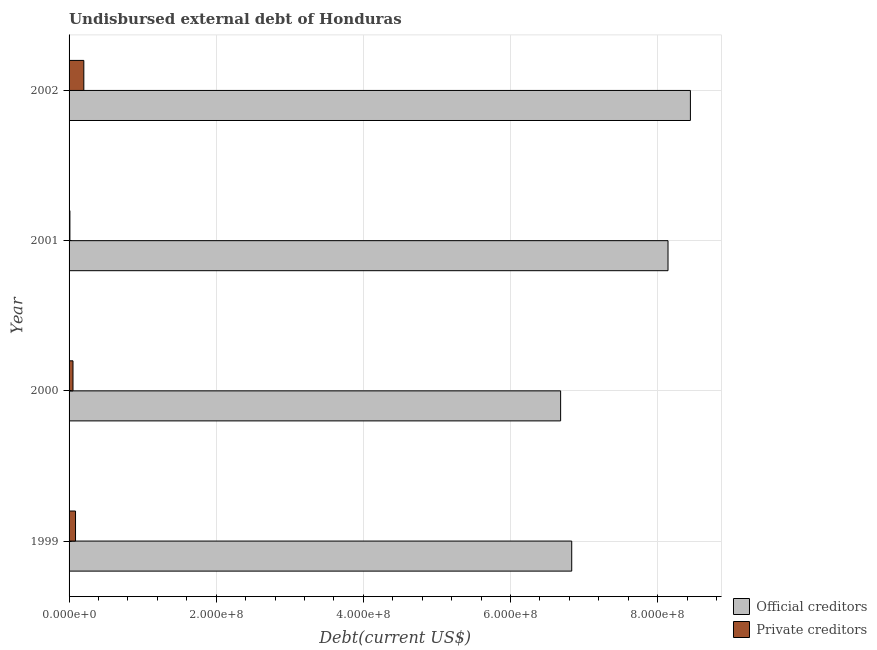How many different coloured bars are there?
Give a very brief answer. 2. Are the number of bars per tick equal to the number of legend labels?
Give a very brief answer. Yes. In how many cases, is the number of bars for a given year not equal to the number of legend labels?
Offer a terse response. 0. What is the undisbursed external debt of official creditors in 1999?
Make the answer very short. 6.83e+08. Across all years, what is the maximum undisbursed external debt of official creditors?
Give a very brief answer. 8.45e+08. Across all years, what is the minimum undisbursed external debt of official creditors?
Keep it short and to the point. 6.68e+08. In which year was the undisbursed external debt of private creditors minimum?
Ensure brevity in your answer.  2001. What is the total undisbursed external debt of private creditors in the graph?
Offer a very short reply. 3.53e+07. What is the difference between the undisbursed external debt of official creditors in 2000 and that in 2001?
Your response must be concise. -1.46e+08. What is the difference between the undisbursed external debt of official creditors in 2002 and the undisbursed external debt of private creditors in 1999?
Make the answer very short. 8.36e+08. What is the average undisbursed external debt of private creditors per year?
Keep it short and to the point. 8.83e+06. In the year 2001, what is the difference between the undisbursed external debt of private creditors and undisbursed external debt of official creditors?
Keep it short and to the point. -8.13e+08. In how many years, is the undisbursed external debt of private creditors greater than 240000000 US$?
Make the answer very short. 0. What is the ratio of the undisbursed external debt of private creditors in 2000 to that in 2002?
Give a very brief answer. 0.27. What is the difference between the highest and the second highest undisbursed external debt of official creditors?
Make the answer very short. 3.04e+07. What is the difference between the highest and the lowest undisbursed external debt of official creditors?
Keep it short and to the point. 1.76e+08. What does the 2nd bar from the top in 1999 represents?
Give a very brief answer. Official creditors. What does the 2nd bar from the bottom in 2000 represents?
Offer a very short reply. Private creditors. Are all the bars in the graph horizontal?
Provide a succinct answer. Yes. What is the difference between two consecutive major ticks on the X-axis?
Make the answer very short. 2.00e+08. Are the values on the major ticks of X-axis written in scientific E-notation?
Your answer should be compact. Yes. Does the graph contain grids?
Offer a terse response. Yes. How many legend labels are there?
Offer a very short reply. 2. How are the legend labels stacked?
Provide a short and direct response. Vertical. What is the title of the graph?
Make the answer very short. Undisbursed external debt of Honduras. Does "Register a business" appear as one of the legend labels in the graph?
Keep it short and to the point. No. What is the label or title of the X-axis?
Ensure brevity in your answer.  Debt(current US$). What is the Debt(current US$) of Official creditors in 1999?
Offer a terse response. 6.83e+08. What is the Debt(current US$) of Private creditors in 1999?
Offer a terse response. 8.78e+06. What is the Debt(current US$) in Official creditors in 2000?
Your response must be concise. 6.68e+08. What is the Debt(current US$) of Private creditors in 2000?
Give a very brief answer. 5.34e+06. What is the Debt(current US$) in Official creditors in 2001?
Provide a succinct answer. 8.14e+08. What is the Debt(current US$) in Private creditors in 2001?
Ensure brevity in your answer.  1.13e+06. What is the Debt(current US$) in Official creditors in 2002?
Give a very brief answer. 8.45e+08. What is the Debt(current US$) in Private creditors in 2002?
Give a very brief answer. 2.01e+07. Across all years, what is the maximum Debt(current US$) in Official creditors?
Give a very brief answer. 8.45e+08. Across all years, what is the maximum Debt(current US$) in Private creditors?
Give a very brief answer. 2.01e+07. Across all years, what is the minimum Debt(current US$) of Official creditors?
Your answer should be compact. 6.68e+08. Across all years, what is the minimum Debt(current US$) of Private creditors?
Ensure brevity in your answer.  1.13e+06. What is the total Debt(current US$) of Official creditors in the graph?
Provide a succinct answer. 3.01e+09. What is the total Debt(current US$) in Private creditors in the graph?
Provide a short and direct response. 3.53e+07. What is the difference between the Debt(current US$) of Official creditors in 1999 and that in 2000?
Offer a very short reply. 1.51e+07. What is the difference between the Debt(current US$) of Private creditors in 1999 and that in 2000?
Offer a terse response. 3.44e+06. What is the difference between the Debt(current US$) of Official creditors in 1999 and that in 2001?
Your answer should be compact. -1.31e+08. What is the difference between the Debt(current US$) of Private creditors in 1999 and that in 2001?
Give a very brief answer. 7.65e+06. What is the difference between the Debt(current US$) of Official creditors in 1999 and that in 2002?
Offer a very short reply. -1.61e+08. What is the difference between the Debt(current US$) of Private creditors in 1999 and that in 2002?
Your answer should be very brief. -1.13e+07. What is the difference between the Debt(current US$) of Official creditors in 2000 and that in 2001?
Make the answer very short. -1.46e+08. What is the difference between the Debt(current US$) in Private creditors in 2000 and that in 2001?
Your answer should be compact. 4.21e+06. What is the difference between the Debt(current US$) in Official creditors in 2000 and that in 2002?
Your answer should be very brief. -1.76e+08. What is the difference between the Debt(current US$) of Private creditors in 2000 and that in 2002?
Offer a very short reply. -1.47e+07. What is the difference between the Debt(current US$) in Official creditors in 2001 and that in 2002?
Your response must be concise. -3.04e+07. What is the difference between the Debt(current US$) in Private creditors in 2001 and that in 2002?
Make the answer very short. -1.89e+07. What is the difference between the Debt(current US$) in Official creditors in 1999 and the Debt(current US$) in Private creditors in 2000?
Make the answer very short. 6.78e+08. What is the difference between the Debt(current US$) in Official creditors in 1999 and the Debt(current US$) in Private creditors in 2001?
Offer a terse response. 6.82e+08. What is the difference between the Debt(current US$) of Official creditors in 1999 and the Debt(current US$) of Private creditors in 2002?
Give a very brief answer. 6.63e+08. What is the difference between the Debt(current US$) of Official creditors in 2000 and the Debt(current US$) of Private creditors in 2001?
Provide a succinct answer. 6.67e+08. What is the difference between the Debt(current US$) in Official creditors in 2000 and the Debt(current US$) in Private creditors in 2002?
Keep it short and to the point. 6.48e+08. What is the difference between the Debt(current US$) in Official creditors in 2001 and the Debt(current US$) in Private creditors in 2002?
Offer a very short reply. 7.94e+08. What is the average Debt(current US$) in Official creditors per year?
Make the answer very short. 7.53e+08. What is the average Debt(current US$) in Private creditors per year?
Make the answer very short. 8.83e+06. In the year 1999, what is the difference between the Debt(current US$) of Official creditors and Debt(current US$) of Private creditors?
Provide a succinct answer. 6.74e+08. In the year 2000, what is the difference between the Debt(current US$) in Official creditors and Debt(current US$) in Private creditors?
Offer a terse response. 6.63e+08. In the year 2001, what is the difference between the Debt(current US$) of Official creditors and Debt(current US$) of Private creditors?
Offer a very short reply. 8.13e+08. In the year 2002, what is the difference between the Debt(current US$) in Official creditors and Debt(current US$) in Private creditors?
Provide a short and direct response. 8.25e+08. What is the ratio of the Debt(current US$) in Official creditors in 1999 to that in 2000?
Your response must be concise. 1.02. What is the ratio of the Debt(current US$) in Private creditors in 1999 to that in 2000?
Provide a succinct answer. 1.65. What is the ratio of the Debt(current US$) of Official creditors in 1999 to that in 2001?
Provide a succinct answer. 0.84. What is the ratio of the Debt(current US$) of Private creditors in 1999 to that in 2001?
Offer a very short reply. 7.76. What is the ratio of the Debt(current US$) in Official creditors in 1999 to that in 2002?
Provide a short and direct response. 0.81. What is the ratio of the Debt(current US$) in Private creditors in 1999 to that in 2002?
Your answer should be compact. 0.44. What is the ratio of the Debt(current US$) of Official creditors in 2000 to that in 2001?
Your answer should be compact. 0.82. What is the ratio of the Debt(current US$) of Private creditors in 2000 to that in 2001?
Provide a short and direct response. 4.72. What is the ratio of the Debt(current US$) of Official creditors in 2000 to that in 2002?
Make the answer very short. 0.79. What is the ratio of the Debt(current US$) of Private creditors in 2000 to that in 2002?
Offer a very short reply. 0.27. What is the ratio of the Debt(current US$) in Official creditors in 2001 to that in 2002?
Offer a terse response. 0.96. What is the ratio of the Debt(current US$) of Private creditors in 2001 to that in 2002?
Ensure brevity in your answer.  0.06. What is the difference between the highest and the second highest Debt(current US$) in Official creditors?
Make the answer very short. 3.04e+07. What is the difference between the highest and the second highest Debt(current US$) of Private creditors?
Your answer should be compact. 1.13e+07. What is the difference between the highest and the lowest Debt(current US$) of Official creditors?
Make the answer very short. 1.76e+08. What is the difference between the highest and the lowest Debt(current US$) of Private creditors?
Your answer should be compact. 1.89e+07. 